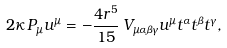Convert formula to latex. <formula><loc_0><loc_0><loc_500><loc_500>2 \kappa \, P _ { \mu } u ^ { \mu } = - \frac { 4 r ^ { 5 } } { 1 5 } \, V _ { \mu \alpha \beta \gamma } u ^ { \mu } t ^ { \alpha } t ^ { \beta } t ^ { \gamma } ,</formula> 